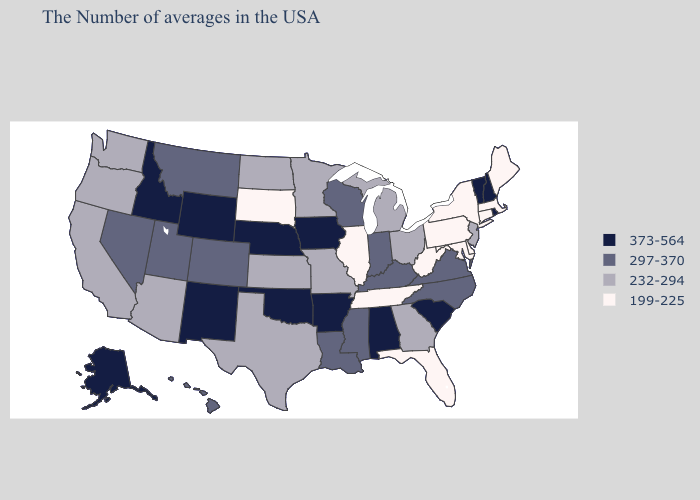Does Vermont have the lowest value in the Northeast?
Write a very short answer. No. Among the states that border Missouri , which have the lowest value?
Short answer required. Tennessee, Illinois. What is the highest value in the West ?
Answer briefly. 373-564. What is the value of Maine?
Quick response, please. 199-225. What is the value of New Jersey?
Write a very short answer. 232-294. What is the value of Arkansas?
Answer briefly. 373-564. Among the states that border Connecticut , does Rhode Island have the highest value?
Short answer required. Yes. What is the value of Oregon?
Write a very short answer. 232-294. Name the states that have a value in the range 232-294?
Concise answer only. New Jersey, Ohio, Georgia, Michigan, Missouri, Minnesota, Kansas, Texas, North Dakota, Arizona, California, Washington, Oregon. What is the lowest value in the West?
Keep it brief. 232-294. Does Nebraska have the highest value in the MidWest?
Concise answer only. Yes. Does Kentucky have a lower value than Tennessee?
Keep it brief. No. What is the value of Louisiana?
Be succinct. 297-370. Does the first symbol in the legend represent the smallest category?
Answer briefly. No. What is the value of New Hampshire?
Give a very brief answer. 373-564. 